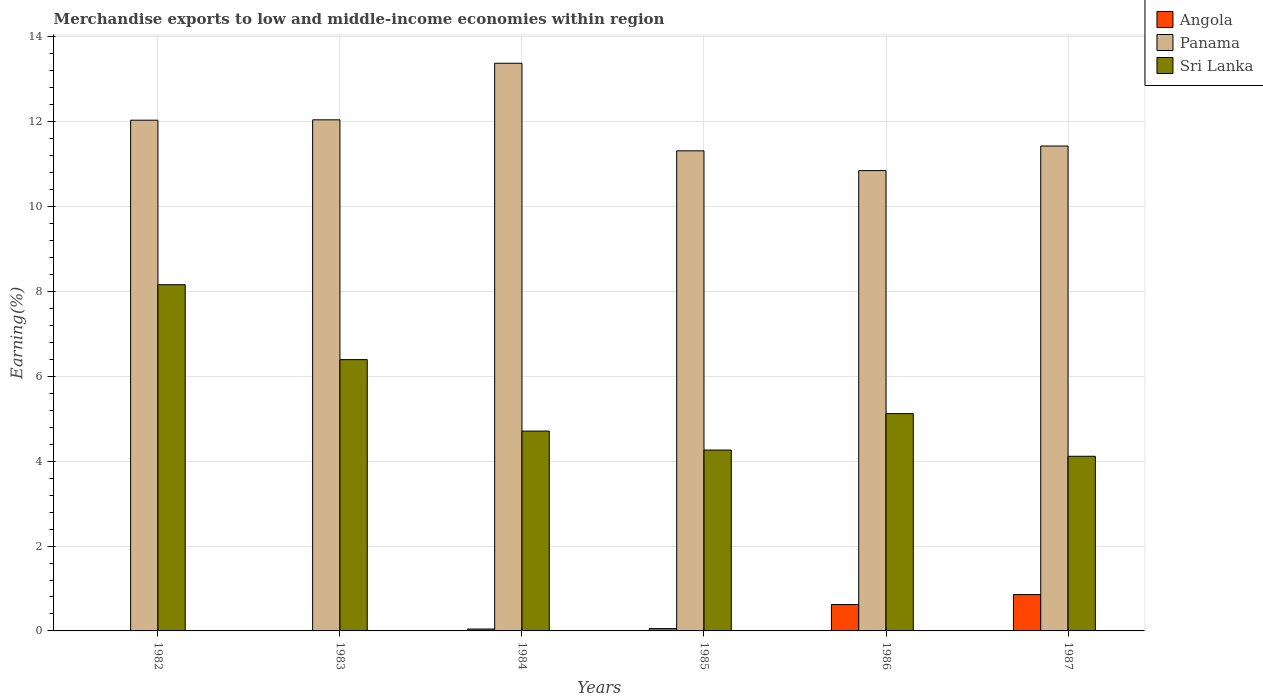How many groups of bars are there?
Offer a very short reply. 6. Are the number of bars per tick equal to the number of legend labels?
Provide a short and direct response. Yes. How many bars are there on the 5th tick from the left?
Your answer should be compact. 3. How many bars are there on the 3rd tick from the right?
Keep it short and to the point. 3. What is the percentage of amount earned from merchandise exports in Angola in 1983?
Provide a succinct answer. 0. Across all years, what is the maximum percentage of amount earned from merchandise exports in Angola?
Provide a short and direct response. 0.86. Across all years, what is the minimum percentage of amount earned from merchandise exports in Angola?
Make the answer very short. 0. In which year was the percentage of amount earned from merchandise exports in Panama minimum?
Your answer should be compact. 1986. What is the total percentage of amount earned from merchandise exports in Sri Lanka in the graph?
Keep it short and to the point. 32.77. What is the difference between the percentage of amount earned from merchandise exports in Angola in 1982 and that in 1986?
Make the answer very short. -0.62. What is the difference between the percentage of amount earned from merchandise exports in Sri Lanka in 1987 and the percentage of amount earned from merchandise exports in Angola in 1983?
Your answer should be very brief. 4.12. What is the average percentage of amount earned from merchandise exports in Sri Lanka per year?
Give a very brief answer. 5.46. In the year 1984, what is the difference between the percentage of amount earned from merchandise exports in Angola and percentage of amount earned from merchandise exports in Sri Lanka?
Your answer should be very brief. -4.67. In how many years, is the percentage of amount earned from merchandise exports in Panama greater than 10.4 %?
Make the answer very short. 6. What is the ratio of the percentage of amount earned from merchandise exports in Sri Lanka in 1985 to that in 1986?
Offer a terse response. 0.83. Is the percentage of amount earned from merchandise exports in Sri Lanka in 1982 less than that in 1985?
Keep it short and to the point. No. Is the difference between the percentage of amount earned from merchandise exports in Angola in 1984 and 1985 greater than the difference between the percentage of amount earned from merchandise exports in Sri Lanka in 1984 and 1985?
Ensure brevity in your answer.  No. What is the difference between the highest and the second highest percentage of amount earned from merchandise exports in Sri Lanka?
Offer a very short reply. 1.77. What is the difference between the highest and the lowest percentage of amount earned from merchandise exports in Angola?
Keep it short and to the point. 0.86. In how many years, is the percentage of amount earned from merchandise exports in Angola greater than the average percentage of amount earned from merchandise exports in Angola taken over all years?
Keep it short and to the point. 2. What does the 1st bar from the left in 1987 represents?
Provide a short and direct response. Angola. What does the 1st bar from the right in 1987 represents?
Offer a terse response. Sri Lanka. Is it the case that in every year, the sum of the percentage of amount earned from merchandise exports in Sri Lanka and percentage of amount earned from merchandise exports in Panama is greater than the percentage of amount earned from merchandise exports in Angola?
Provide a short and direct response. Yes. How many bars are there?
Provide a succinct answer. 18. How many years are there in the graph?
Give a very brief answer. 6. What is the difference between two consecutive major ticks on the Y-axis?
Keep it short and to the point. 2. Are the values on the major ticks of Y-axis written in scientific E-notation?
Provide a short and direct response. No. Does the graph contain any zero values?
Your answer should be very brief. No. Does the graph contain grids?
Make the answer very short. Yes. Where does the legend appear in the graph?
Your response must be concise. Top right. How many legend labels are there?
Your answer should be compact. 3. What is the title of the graph?
Your answer should be compact. Merchandise exports to low and middle-income economies within region. Does "Turks and Caicos Islands" appear as one of the legend labels in the graph?
Keep it short and to the point. No. What is the label or title of the Y-axis?
Provide a short and direct response. Earning(%). What is the Earning(%) of Angola in 1982?
Keep it short and to the point. 0. What is the Earning(%) of Panama in 1982?
Your response must be concise. 12.04. What is the Earning(%) in Sri Lanka in 1982?
Keep it short and to the point. 8.16. What is the Earning(%) of Angola in 1983?
Your answer should be very brief. 0. What is the Earning(%) of Panama in 1983?
Your answer should be very brief. 12.05. What is the Earning(%) in Sri Lanka in 1983?
Ensure brevity in your answer.  6.39. What is the Earning(%) of Angola in 1984?
Your answer should be very brief. 0.04. What is the Earning(%) in Panama in 1984?
Keep it short and to the point. 13.38. What is the Earning(%) of Sri Lanka in 1984?
Offer a very short reply. 4.71. What is the Earning(%) in Angola in 1985?
Your answer should be very brief. 0.05. What is the Earning(%) in Panama in 1985?
Offer a terse response. 11.32. What is the Earning(%) of Sri Lanka in 1985?
Your response must be concise. 4.26. What is the Earning(%) in Angola in 1986?
Ensure brevity in your answer.  0.62. What is the Earning(%) of Panama in 1986?
Offer a very short reply. 10.85. What is the Earning(%) in Sri Lanka in 1986?
Your answer should be very brief. 5.12. What is the Earning(%) of Angola in 1987?
Your answer should be very brief. 0.86. What is the Earning(%) of Panama in 1987?
Provide a short and direct response. 11.43. What is the Earning(%) in Sri Lanka in 1987?
Provide a succinct answer. 4.12. Across all years, what is the maximum Earning(%) in Angola?
Your answer should be very brief. 0.86. Across all years, what is the maximum Earning(%) of Panama?
Your answer should be very brief. 13.38. Across all years, what is the maximum Earning(%) in Sri Lanka?
Give a very brief answer. 8.16. Across all years, what is the minimum Earning(%) in Angola?
Your answer should be very brief. 0. Across all years, what is the minimum Earning(%) in Panama?
Offer a terse response. 10.85. Across all years, what is the minimum Earning(%) in Sri Lanka?
Your answer should be very brief. 4.12. What is the total Earning(%) in Angola in the graph?
Give a very brief answer. 1.58. What is the total Earning(%) in Panama in the graph?
Keep it short and to the point. 71.06. What is the total Earning(%) in Sri Lanka in the graph?
Your response must be concise. 32.77. What is the difference between the Earning(%) of Angola in 1982 and that in 1983?
Provide a succinct answer. -0. What is the difference between the Earning(%) in Panama in 1982 and that in 1983?
Make the answer very short. -0.01. What is the difference between the Earning(%) in Sri Lanka in 1982 and that in 1983?
Offer a very short reply. 1.77. What is the difference between the Earning(%) of Angola in 1982 and that in 1984?
Your answer should be compact. -0.04. What is the difference between the Earning(%) in Panama in 1982 and that in 1984?
Your answer should be compact. -1.34. What is the difference between the Earning(%) of Sri Lanka in 1982 and that in 1984?
Keep it short and to the point. 3.45. What is the difference between the Earning(%) in Angola in 1982 and that in 1985?
Offer a very short reply. -0.05. What is the difference between the Earning(%) of Panama in 1982 and that in 1985?
Your response must be concise. 0.72. What is the difference between the Earning(%) in Sri Lanka in 1982 and that in 1985?
Offer a terse response. 3.9. What is the difference between the Earning(%) in Angola in 1982 and that in 1986?
Your answer should be very brief. -0.62. What is the difference between the Earning(%) in Panama in 1982 and that in 1986?
Provide a succinct answer. 1.19. What is the difference between the Earning(%) of Sri Lanka in 1982 and that in 1986?
Your answer should be very brief. 3.04. What is the difference between the Earning(%) in Angola in 1982 and that in 1987?
Offer a very short reply. -0.86. What is the difference between the Earning(%) in Panama in 1982 and that in 1987?
Your response must be concise. 0.61. What is the difference between the Earning(%) in Sri Lanka in 1982 and that in 1987?
Your answer should be compact. 4.04. What is the difference between the Earning(%) of Angola in 1983 and that in 1984?
Ensure brevity in your answer.  -0.04. What is the difference between the Earning(%) of Panama in 1983 and that in 1984?
Offer a very short reply. -1.33. What is the difference between the Earning(%) of Sri Lanka in 1983 and that in 1984?
Provide a short and direct response. 1.68. What is the difference between the Earning(%) of Angola in 1983 and that in 1985?
Make the answer very short. -0.05. What is the difference between the Earning(%) of Panama in 1983 and that in 1985?
Provide a short and direct response. 0.73. What is the difference between the Earning(%) in Sri Lanka in 1983 and that in 1985?
Your answer should be compact. 2.13. What is the difference between the Earning(%) in Angola in 1983 and that in 1986?
Offer a very short reply. -0.62. What is the difference between the Earning(%) in Panama in 1983 and that in 1986?
Your answer should be very brief. 1.2. What is the difference between the Earning(%) in Sri Lanka in 1983 and that in 1986?
Give a very brief answer. 1.27. What is the difference between the Earning(%) of Angola in 1983 and that in 1987?
Provide a succinct answer. -0.86. What is the difference between the Earning(%) in Panama in 1983 and that in 1987?
Give a very brief answer. 0.62. What is the difference between the Earning(%) of Sri Lanka in 1983 and that in 1987?
Give a very brief answer. 2.28. What is the difference between the Earning(%) of Angola in 1984 and that in 1985?
Make the answer very short. -0.01. What is the difference between the Earning(%) of Panama in 1984 and that in 1985?
Offer a very short reply. 2.06. What is the difference between the Earning(%) in Sri Lanka in 1984 and that in 1985?
Your response must be concise. 0.45. What is the difference between the Earning(%) in Angola in 1984 and that in 1986?
Offer a terse response. -0.58. What is the difference between the Earning(%) in Panama in 1984 and that in 1986?
Make the answer very short. 2.53. What is the difference between the Earning(%) in Sri Lanka in 1984 and that in 1986?
Ensure brevity in your answer.  -0.41. What is the difference between the Earning(%) of Angola in 1984 and that in 1987?
Provide a succinct answer. -0.81. What is the difference between the Earning(%) in Panama in 1984 and that in 1987?
Offer a very short reply. 1.95. What is the difference between the Earning(%) of Sri Lanka in 1984 and that in 1987?
Provide a short and direct response. 0.59. What is the difference between the Earning(%) in Angola in 1985 and that in 1986?
Offer a terse response. -0.57. What is the difference between the Earning(%) of Panama in 1985 and that in 1986?
Ensure brevity in your answer.  0.47. What is the difference between the Earning(%) in Sri Lanka in 1985 and that in 1986?
Give a very brief answer. -0.86. What is the difference between the Earning(%) of Angola in 1985 and that in 1987?
Keep it short and to the point. -0.8. What is the difference between the Earning(%) in Panama in 1985 and that in 1987?
Offer a terse response. -0.11. What is the difference between the Earning(%) of Sri Lanka in 1985 and that in 1987?
Your answer should be compact. 0.15. What is the difference between the Earning(%) of Angola in 1986 and that in 1987?
Your answer should be very brief. -0.23. What is the difference between the Earning(%) of Panama in 1986 and that in 1987?
Your answer should be very brief. -0.58. What is the difference between the Earning(%) in Angola in 1982 and the Earning(%) in Panama in 1983?
Your answer should be compact. -12.05. What is the difference between the Earning(%) of Angola in 1982 and the Earning(%) of Sri Lanka in 1983?
Your answer should be very brief. -6.39. What is the difference between the Earning(%) of Panama in 1982 and the Earning(%) of Sri Lanka in 1983?
Ensure brevity in your answer.  5.64. What is the difference between the Earning(%) in Angola in 1982 and the Earning(%) in Panama in 1984?
Your answer should be very brief. -13.38. What is the difference between the Earning(%) of Angola in 1982 and the Earning(%) of Sri Lanka in 1984?
Your response must be concise. -4.71. What is the difference between the Earning(%) in Panama in 1982 and the Earning(%) in Sri Lanka in 1984?
Give a very brief answer. 7.33. What is the difference between the Earning(%) in Angola in 1982 and the Earning(%) in Panama in 1985?
Keep it short and to the point. -11.32. What is the difference between the Earning(%) of Angola in 1982 and the Earning(%) of Sri Lanka in 1985?
Your response must be concise. -4.26. What is the difference between the Earning(%) of Panama in 1982 and the Earning(%) of Sri Lanka in 1985?
Provide a short and direct response. 7.77. What is the difference between the Earning(%) of Angola in 1982 and the Earning(%) of Panama in 1986?
Keep it short and to the point. -10.85. What is the difference between the Earning(%) in Angola in 1982 and the Earning(%) in Sri Lanka in 1986?
Offer a terse response. -5.12. What is the difference between the Earning(%) of Panama in 1982 and the Earning(%) of Sri Lanka in 1986?
Make the answer very short. 6.92. What is the difference between the Earning(%) in Angola in 1982 and the Earning(%) in Panama in 1987?
Provide a succinct answer. -11.43. What is the difference between the Earning(%) of Angola in 1982 and the Earning(%) of Sri Lanka in 1987?
Provide a succinct answer. -4.12. What is the difference between the Earning(%) in Panama in 1982 and the Earning(%) in Sri Lanka in 1987?
Keep it short and to the point. 7.92. What is the difference between the Earning(%) in Angola in 1983 and the Earning(%) in Panama in 1984?
Your answer should be compact. -13.38. What is the difference between the Earning(%) in Angola in 1983 and the Earning(%) in Sri Lanka in 1984?
Your answer should be very brief. -4.71. What is the difference between the Earning(%) of Panama in 1983 and the Earning(%) of Sri Lanka in 1984?
Give a very brief answer. 7.34. What is the difference between the Earning(%) of Angola in 1983 and the Earning(%) of Panama in 1985?
Your response must be concise. -11.32. What is the difference between the Earning(%) in Angola in 1983 and the Earning(%) in Sri Lanka in 1985?
Make the answer very short. -4.26. What is the difference between the Earning(%) of Panama in 1983 and the Earning(%) of Sri Lanka in 1985?
Your answer should be compact. 7.78. What is the difference between the Earning(%) in Angola in 1983 and the Earning(%) in Panama in 1986?
Your answer should be very brief. -10.85. What is the difference between the Earning(%) of Angola in 1983 and the Earning(%) of Sri Lanka in 1986?
Your answer should be very brief. -5.12. What is the difference between the Earning(%) in Panama in 1983 and the Earning(%) in Sri Lanka in 1986?
Provide a short and direct response. 6.92. What is the difference between the Earning(%) of Angola in 1983 and the Earning(%) of Panama in 1987?
Offer a terse response. -11.43. What is the difference between the Earning(%) of Angola in 1983 and the Earning(%) of Sri Lanka in 1987?
Make the answer very short. -4.12. What is the difference between the Earning(%) in Panama in 1983 and the Earning(%) in Sri Lanka in 1987?
Give a very brief answer. 7.93. What is the difference between the Earning(%) of Angola in 1984 and the Earning(%) of Panama in 1985?
Give a very brief answer. -11.27. What is the difference between the Earning(%) of Angola in 1984 and the Earning(%) of Sri Lanka in 1985?
Give a very brief answer. -4.22. What is the difference between the Earning(%) of Panama in 1984 and the Earning(%) of Sri Lanka in 1985?
Provide a short and direct response. 9.12. What is the difference between the Earning(%) of Angola in 1984 and the Earning(%) of Panama in 1986?
Make the answer very short. -10.8. What is the difference between the Earning(%) in Angola in 1984 and the Earning(%) in Sri Lanka in 1986?
Offer a terse response. -5.08. What is the difference between the Earning(%) in Panama in 1984 and the Earning(%) in Sri Lanka in 1986?
Your response must be concise. 8.26. What is the difference between the Earning(%) of Angola in 1984 and the Earning(%) of Panama in 1987?
Your answer should be compact. -11.38. What is the difference between the Earning(%) of Angola in 1984 and the Earning(%) of Sri Lanka in 1987?
Offer a very short reply. -4.07. What is the difference between the Earning(%) of Panama in 1984 and the Earning(%) of Sri Lanka in 1987?
Offer a terse response. 9.26. What is the difference between the Earning(%) in Angola in 1985 and the Earning(%) in Panama in 1986?
Offer a terse response. -10.8. What is the difference between the Earning(%) of Angola in 1985 and the Earning(%) of Sri Lanka in 1986?
Make the answer very short. -5.07. What is the difference between the Earning(%) in Panama in 1985 and the Earning(%) in Sri Lanka in 1986?
Keep it short and to the point. 6.19. What is the difference between the Earning(%) of Angola in 1985 and the Earning(%) of Panama in 1987?
Provide a succinct answer. -11.37. What is the difference between the Earning(%) of Angola in 1985 and the Earning(%) of Sri Lanka in 1987?
Provide a succinct answer. -4.06. What is the difference between the Earning(%) of Panama in 1985 and the Earning(%) of Sri Lanka in 1987?
Ensure brevity in your answer.  7.2. What is the difference between the Earning(%) of Angola in 1986 and the Earning(%) of Panama in 1987?
Your answer should be compact. -10.81. What is the difference between the Earning(%) of Angola in 1986 and the Earning(%) of Sri Lanka in 1987?
Keep it short and to the point. -3.49. What is the difference between the Earning(%) in Panama in 1986 and the Earning(%) in Sri Lanka in 1987?
Provide a short and direct response. 6.73. What is the average Earning(%) of Angola per year?
Give a very brief answer. 0.26. What is the average Earning(%) of Panama per year?
Keep it short and to the point. 11.84. What is the average Earning(%) of Sri Lanka per year?
Provide a short and direct response. 5.46. In the year 1982, what is the difference between the Earning(%) in Angola and Earning(%) in Panama?
Your answer should be compact. -12.04. In the year 1982, what is the difference between the Earning(%) in Angola and Earning(%) in Sri Lanka?
Your answer should be compact. -8.16. In the year 1982, what is the difference between the Earning(%) of Panama and Earning(%) of Sri Lanka?
Make the answer very short. 3.88. In the year 1983, what is the difference between the Earning(%) of Angola and Earning(%) of Panama?
Provide a short and direct response. -12.05. In the year 1983, what is the difference between the Earning(%) of Angola and Earning(%) of Sri Lanka?
Your answer should be compact. -6.39. In the year 1983, what is the difference between the Earning(%) of Panama and Earning(%) of Sri Lanka?
Give a very brief answer. 5.65. In the year 1984, what is the difference between the Earning(%) in Angola and Earning(%) in Panama?
Your answer should be very brief. -13.34. In the year 1984, what is the difference between the Earning(%) of Angola and Earning(%) of Sri Lanka?
Offer a terse response. -4.67. In the year 1984, what is the difference between the Earning(%) of Panama and Earning(%) of Sri Lanka?
Make the answer very short. 8.67. In the year 1985, what is the difference between the Earning(%) of Angola and Earning(%) of Panama?
Offer a terse response. -11.26. In the year 1985, what is the difference between the Earning(%) in Angola and Earning(%) in Sri Lanka?
Your answer should be compact. -4.21. In the year 1985, what is the difference between the Earning(%) in Panama and Earning(%) in Sri Lanka?
Provide a succinct answer. 7.05. In the year 1986, what is the difference between the Earning(%) of Angola and Earning(%) of Panama?
Ensure brevity in your answer.  -10.23. In the year 1986, what is the difference between the Earning(%) of Angola and Earning(%) of Sri Lanka?
Provide a short and direct response. -4.5. In the year 1986, what is the difference between the Earning(%) of Panama and Earning(%) of Sri Lanka?
Give a very brief answer. 5.73. In the year 1987, what is the difference between the Earning(%) of Angola and Earning(%) of Panama?
Your answer should be compact. -10.57. In the year 1987, what is the difference between the Earning(%) of Angola and Earning(%) of Sri Lanka?
Ensure brevity in your answer.  -3.26. In the year 1987, what is the difference between the Earning(%) in Panama and Earning(%) in Sri Lanka?
Offer a very short reply. 7.31. What is the ratio of the Earning(%) in Angola in 1982 to that in 1983?
Offer a very short reply. 0.5. What is the ratio of the Earning(%) in Panama in 1982 to that in 1983?
Your response must be concise. 1. What is the ratio of the Earning(%) of Sri Lanka in 1982 to that in 1983?
Provide a short and direct response. 1.28. What is the ratio of the Earning(%) in Angola in 1982 to that in 1984?
Your response must be concise. 0.01. What is the ratio of the Earning(%) in Panama in 1982 to that in 1984?
Keep it short and to the point. 0.9. What is the ratio of the Earning(%) in Sri Lanka in 1982 to that in 1984?
Give a very brief answer. 1.73. What is the ratio of the Earning(%) of Angola in 1982 to that in 1985?
Provide a short and direct response. 0.01. What is the ratio of the Earning(%) of Panama in 1982 to that in 1985?
Offer a very short reply. 1.06. What is the ratio of the Earning(%) of Sri Lanka in 1982 to that in 1985?
Give a very brief answer. 1.91. What is the ratio of the Earning(%) in Panama in 1982 to that in 1986?
Offer a terse response. 1.11. What is the ratio of the Earning(%) in Sri Lanka in 1982 to that in 1986?
Your response must be concise. 1.59. What is the ratio of the Earning(%) of Panama in 1982 to that in 1987?
Offer a terse response. 1.05. What is the ratio of the Earning(%) in Sri Lanka in 1982 to that in 1987?
Provide a succinct answer. 1.98. What is the ratio of the Earning(%) in Angola in 1983 to that in 1984?
Ensure brevity in your answer.  0.01. What is the ratio of the Earning(%) in Panama in 1983 to that in 1984?
Provide a succinct answer. 0.9. What is the ratio of the Earning(%) in Sri Lanka in 1983 to that in 1984?
Your answer should be very brief. 1.36. What is the ratio of the Earning(%) in Angola in 1983 to that in 1985?
Make the answer very short. 0.01. What is the ratio of the Earning(%) of Panama in 1983 to that in 1985?
Your answer should be compact. 1.06. What is the ratio of the Earning(%) in Sri Lanka in 1983 to that in 1985?
Keep it short and to the point. 1.5. What is the ratio of the Earning(%) of Angola in 1983 to that in 1986?
Provide a succinct answer. 0. What is the ratio of the Earning(%) of Panama in 1983 to that in 1986?
Your response must be concise. 1.11. What is the ratio of the Earning(%) of Sri Lanka in 1983 to that in 1986?
Make the answer very short. 1.25. What is the ratio of the Earning(%) of Angola in 1983 to that in 1987?
Your response must be concise. 0. What is the ratio of the Earning(%) of Panama in 1983 to that in 1987?
Provide a short and direct response. 1.05. What is the ratio of the Earning(%) of Sri Lanka in 1983 to that in 1987?
Your answer should be compact. 1.55. What is the ratio of the Earning(%) in Angola in 1984 to that in 1985?
Make the answer very short. 0.82. What is the ratio of the Earning(%) of Panama in 1984 to that in 1985?
Give a very brief answer. 1.18. What is the ratio of the Earning(%) in Sri Lanka in 1984 to that in 1985?
Provide a succinct answer. 1.1. What is the ratio of the Earning(%) of Angola in 1984 to that in 1986?
Offer a very short reply. 0.07. What is the ratio of the Earning(%) of Panama in 1984 to that in 1986?
Offer a very short reply. 1.23. What is the ratio of the Earning(%) of Sri Lanka in 1984 to that in 1986?
Offer a terse response. 0.92. What is the ratio of the Earning(%) in Angola in 1984 to that in 1987?
Make the answer very short. 0.05. What is the ratio of the Earning(%) in Panama in 1984 to that in 1987?
Offer a very short reply. 1.17. What is the ratio of the Earning(%) in Sri Lanka in 1984 to that in 1987?
Your response must be concise. 1.14. What is the ratio of the Earning(%) in Angola in 1985 to that in 1986?
Your answer should be compact. 0.09. What is the ratio of the Earning(%) in Panama in 1985 to that in 1986?
Give a very brief answer. 1.04. What is the ratio of the Earning(%) in Sri Lanka in 1985 to that in 1986?
Offer a very short reply. 0.83. What is the ratio of the Earning(%) in Angola in 1985 to that in 1987?
Provide a succinct answer. 0.06. What is the ratio of the Earning(%) in Panama in 1985 to that in 1987?
Offer a terse response. 0.99. What is the ratio of the Earning(%) in Sri Lanka in 1985 to that in 1987?
Your response must be concise. 1.04. What is the ratio of the Earning(%) of Angola in 1986 to that in 1987?
Make the answer very short. 0.73. What is the ratio of the Earning(%) in Panama in 1986 to that in 1987?
Your response must be concise. 0.95. What is the ratio of the Earning(%) in Sri Lanka in 1986 to that in 1987?
Offer a terse response. 1.24. What is the difference between the highest and the second highest Earning(%) in Angola?
Keep it short and to the point. 0.23. What is the difference between the highest and the second highest Earning(%) in Panama?
Provide a succinct answer. 1.33. What is the difference between the highest and the second highest Earning(%) of Sri Lanka?
Make the answer very short. 1.77. What is the difference between the highest and the lowest Earning(%) in Angola?
Give a very brief answer. 0.86. What is the difference between the highest and the lowest Earning(%) in Panama?
Offer a very short reply. 2.53. What is the difference between the highest and the lowest Earning(%) in Sri Lanka?
Your response must be concise. 4.04. 